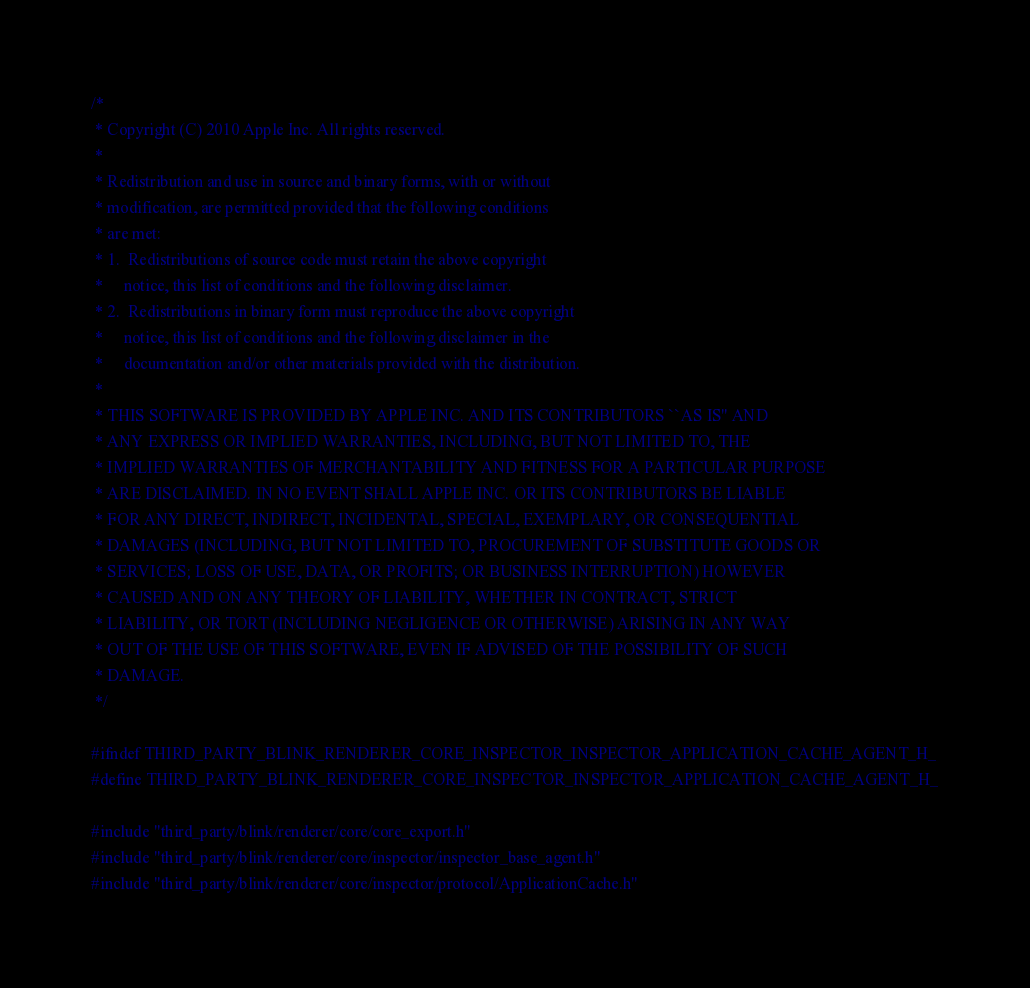<code> <loc_0><loc_0><loc_500><loc_500><_C_>/*
 * Copyright (C) 2010 Apple Inc. All rights reserved.
 *
 * Redistribution and use in source and binary forms, with or without
 * modification, are permitted provided that the following conditions
 * are met:
 * 1.  Redistributions of source code must retain the above copyright
 *     notice, this list of conditions and the following disclaimer.
 * 2.  Redistributions in binary form must reproduce the above copyright
 *     notice, this list of conditions and the following disclaimer in the
 *     documentation and/or other materials provided with the distribution.
 *
 * THIS SOFTWARE IS PROVIDED BY APPLE INC. AND ITS CONTRIBUTORS ``AS IS'' AND
 * ANY EXPRESS OR IMPLIED WARRANTIES, INCLUDING, BUT NOT LIMITED TO, THE
 * IMPLIED WARRANTIES OF MERCHANTABILITY AND FITNESS FOR A PARTICULAR PURPOSE
 * ARE DISCLAIMED. IN NO EVENT SHALL APPLE INC. OR ITS CONTRIBUTORS BE LIABLE
 * FOR ANY DIRECT, INDIRECT, INCIDENTAL, SPECIAL, EXEMPLARY, OR CONSEQUENTIAL
 * DAMAGES (INCLUDING, BUT NOT LIMITED TO, PROCUREMENT OF SUBSTITUTE GOODS OR
 * SERVICES; LOSS OF USE, DATA, OR PROFITS; OR BUSINESS INTERRUPTION) HOWEVER
 * CAUSED AND ON ANY THEORY OF LIABILITY, WHETHER IN CONTRACT, STRICT
 * LIABILITY, OR TORT (INCLUDING NEGLIGENCE OR OTHERWISE) ARISING IN ANY WAY
 * OUT OF THE USE OF THIS SOFTWARE, EVEN IF ADVISED OF THE POSSIBILITY OF SUCH
 * DAMAGE.
 */

#ifndef THIRD_PARTY_BLINK_RENDERER_CORE_INSPECTOR_INSPECTOR_APPLICATION_CACHE_AGENT_H_
#define THIRD_PARTY_BLINK_RENDERER_CORE_INSPECTOR_INSPECTOR_APPLICATION_CACHE_AGENT_H_

#include "third_party/blink/renderer/core/core_export.h"
#include "third_party/blink/renderer/core/inspector/inspector_base_agent.h"
#include "third_party/blink/renderer/core/inspector/protocol/ApplicationCache.h"</code> 